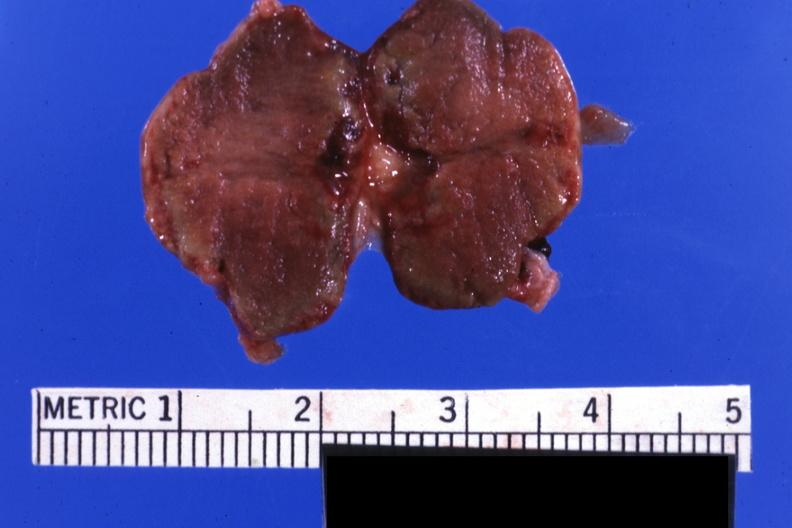what is present?
Answer the question using a single word or phrase. Endocrine 